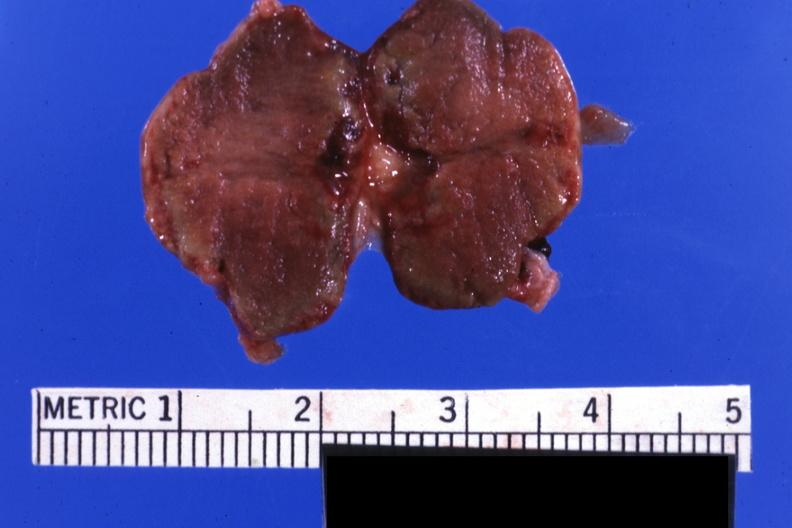what is present?
Answer the question using a single word or phrase. Endocrine 